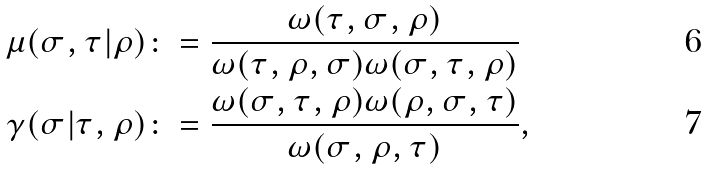Convert formula to latex. <formula><loc_0><loc_0><loc_500><loc_500>\mu ( \sigma , \tau | \rho ) & \colon = \frac { \omega ( \tau , \sigma , \rho ) } { \omega ( \tau , \rho , \sigma ) \omega ( \sigma , \tau , \rho ) } \\ \gamma ( \sigma | \tau , \rho ) & \colon = \frac { \omega ( \sigma , \tau , \rho ) \omega ( \rho , \sigma , \tau ) } { \omega ( \sigma , \rho , \tau ) } ,</formula> 